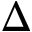<formula> <loc_0><loc_0><loc_500><loc_500>\Delta</formula> 